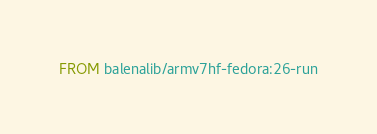Convert code to text. <code><loc_0><loc_0><loc_500><loc_500><_Dockerfile_>FROM balenalib/armv7hf-fedora:26-run</code> 